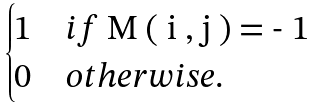Convert formula to latex. <formula><loc_0><loc_0><loc_500><loc_500>\begin{cases} 1 & i f $ M ( i , j ) = - 1 $ \\ 0 & o t h e r w i s e . \end{cases}</formula> 